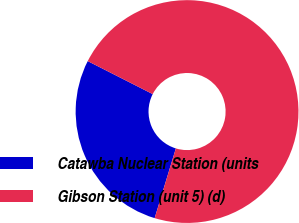<chart> <loc_0><loc_0><loc_500><loc_500><pie_chart><fcel>Catawba Nuclear Station (units<fcel>Gibson Station (unit 5) (d)<nl><fcel>27.78%<fcel>72.22%<nl></chart> 